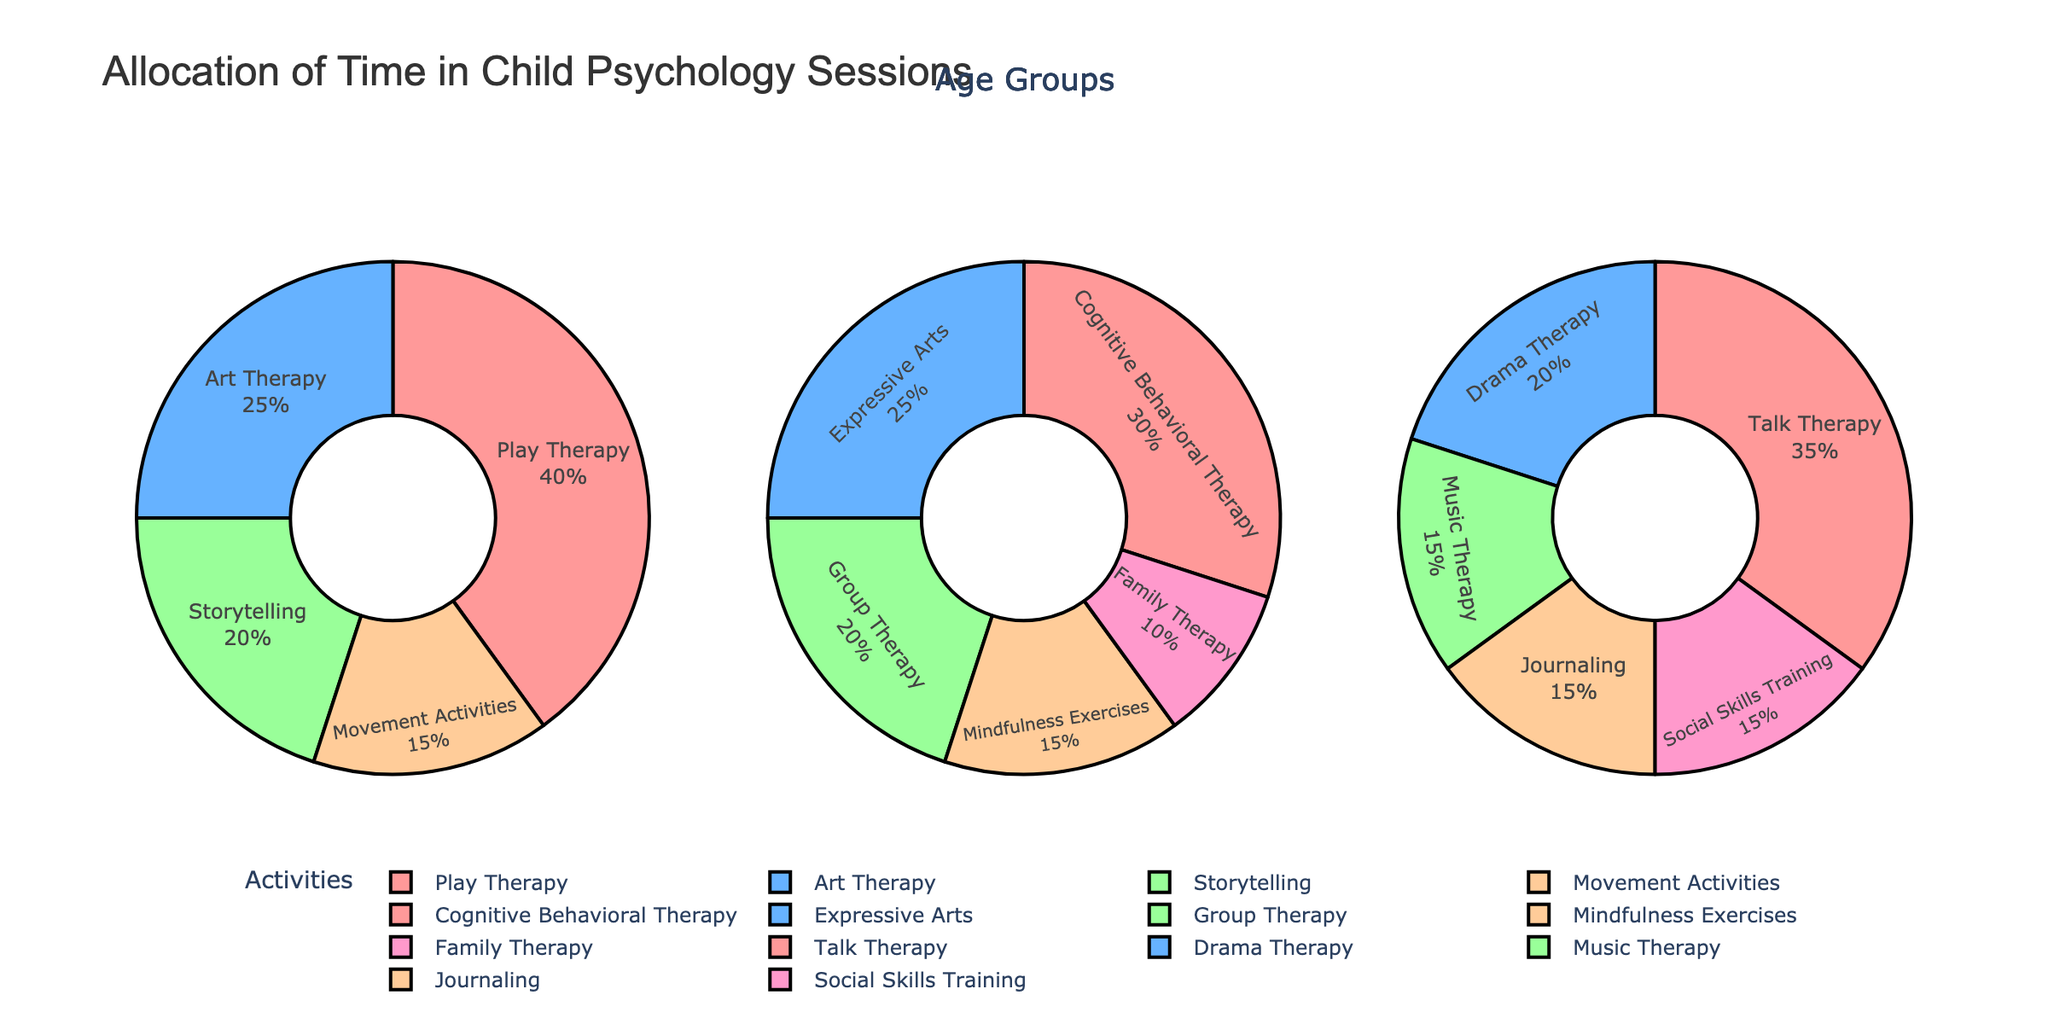what is the primary activity for the 3-6 years age group? The largest portion of the pie chart for the 3-6 years age group is allocated to Play Therapy.
Answer: Play Therapy Which age group spends the highest percentage of sessions on cognitive behavioral therapy? Look at the distribution of Cognitive Behavioral Therapy in each age group. It appears only in the 7-12 years age group's pie chart at 30%.
Answer: 7-12 years How much more percentage is spent on Play Therapy compared to Movement Activities for the 3-6 years age group? The percentages for Play Therapy and Movement Activities in the 3-6 age group are 40% and 15%, respectively. The difference is 40 - 15.
Answer: 25% In which age group is Journaling used, and what percentage of time is allocated to it? Examine the pie charts for the presence of Journaling; it appears in the 13-17 years age group at 15%.
Answer: 13-17 years, 15% Which activity is used equally in two different age groups? Scan all pie charts to identify an activity with the same percentage allocation in different age groups. Mindfulness Exercises and Movement Activities are the same at 15% in 3-6 and 7-12.
Answer: Mindfulness Exercises What is the total percentage allocated to Expressive Arts and Group Therapy for the 7-12 years age group? Add the percentages of Expressive Arts (25%) and Group Therapy (20%) in the 7-12 age group. The total is 25 + 20.
Answer: 45% Compare the percentage of time allocated to Drama Therapy and Music Therapy for the 13-17 years age group. Which one receives more, and by how much? The percentages for Drama Therapy and Music Therapy in the 13-17 age group are 20% and 15%, respectively. The difference is 20 - 15.
Answer: Drama Therapy by 5% How many different activities are depicted in the pie chart for the 13-17 years age group? Count the distinct activities shown in the 13-17 years age group pie chart.
Answer: 5 What combined percentage of time is allocated to Creative Arts across all age groups? Creative Arts include Art Therapy (25% in 3-6 years) and Expressive Arts (25% in 7-12 years).
Answer: 50% 